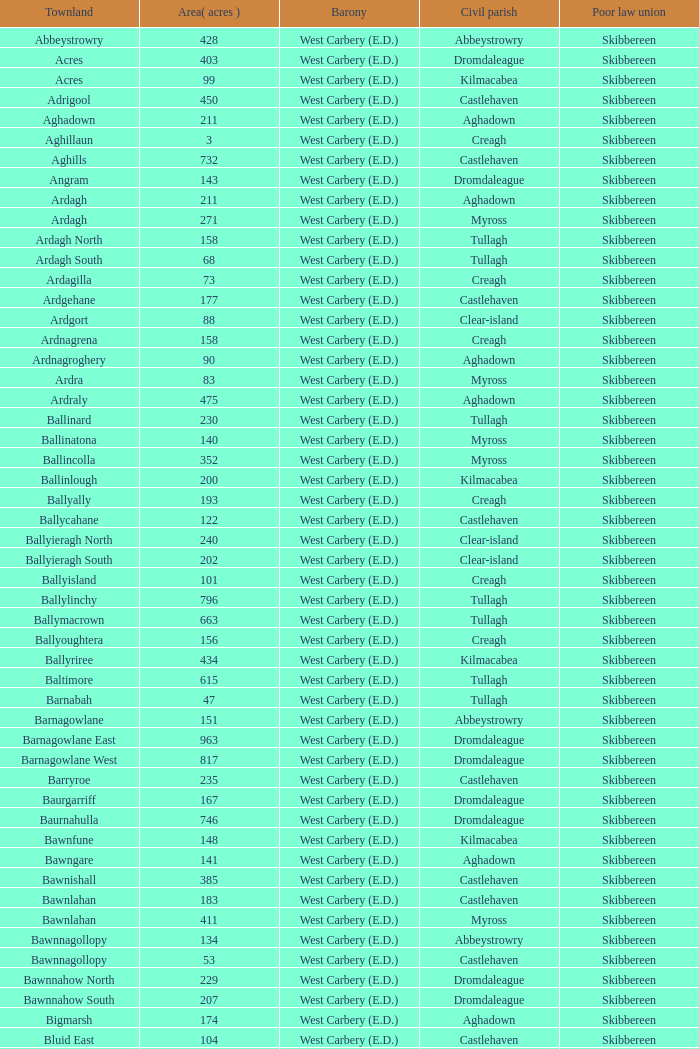In the context of a 142-acre area, what is the meaning of poor law unions? Skibbereen. 